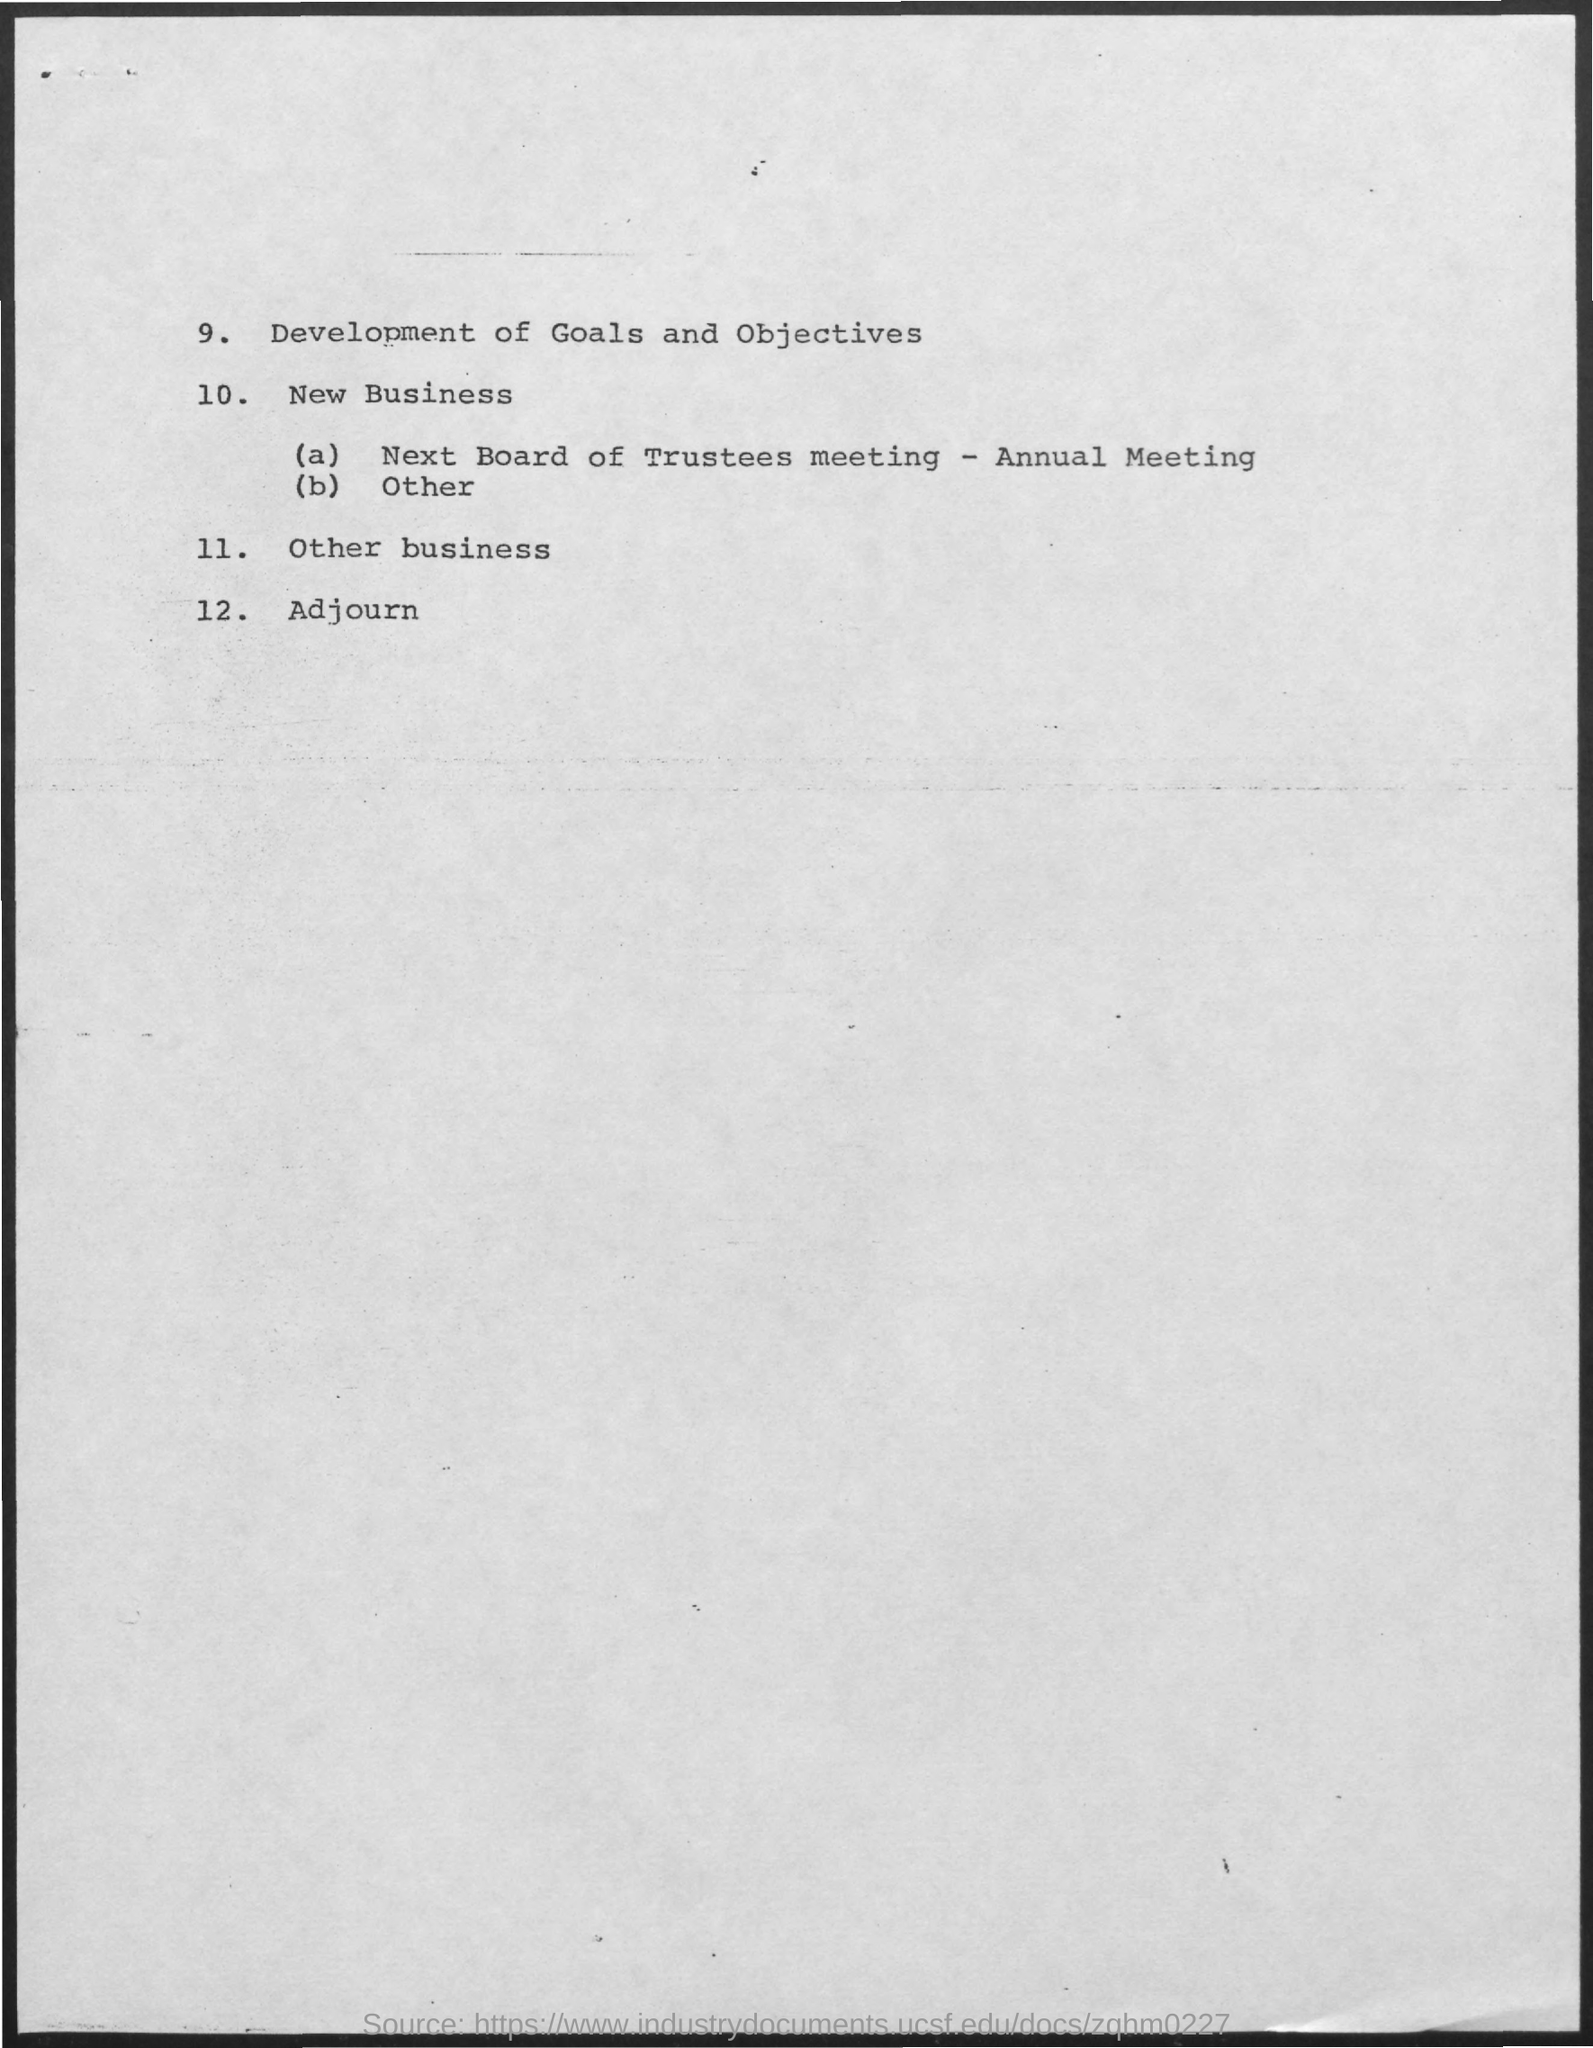Point out several critical features in this image. The 12th point is Adjourn, which is a declaration made during a meeting to end the proceedings for the day or to reconvene at a later time. 